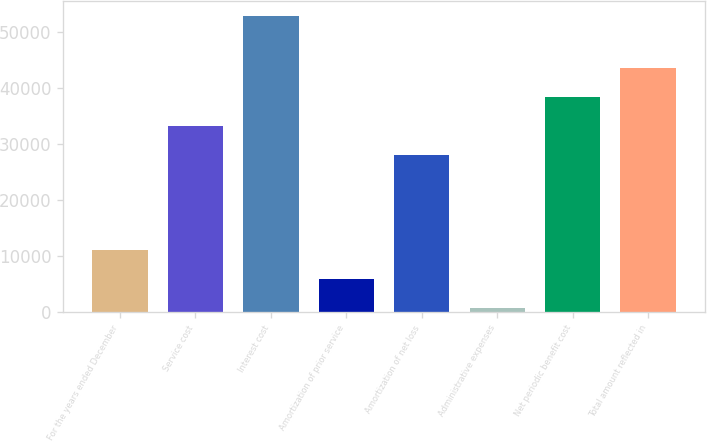<chart> <loc_0><loc_0><loc_500><loc_500><bar_chart><fcel>For the years ended December<fcel>Service cost<fcel>Interest cost<fcel>Amortization of prior service<fcel>Amortization of net loss<fcel>Administrative expenses<fcel>Net periodic benefit cost<fcel>Total amount reflected in<nl><fcel>11114.4<fcel>33234.7<fcel>52960<fcel>5883.7<fcel>28004<fcel>653<fcel>38465.4<fcel>43696.1<nl></chart> 